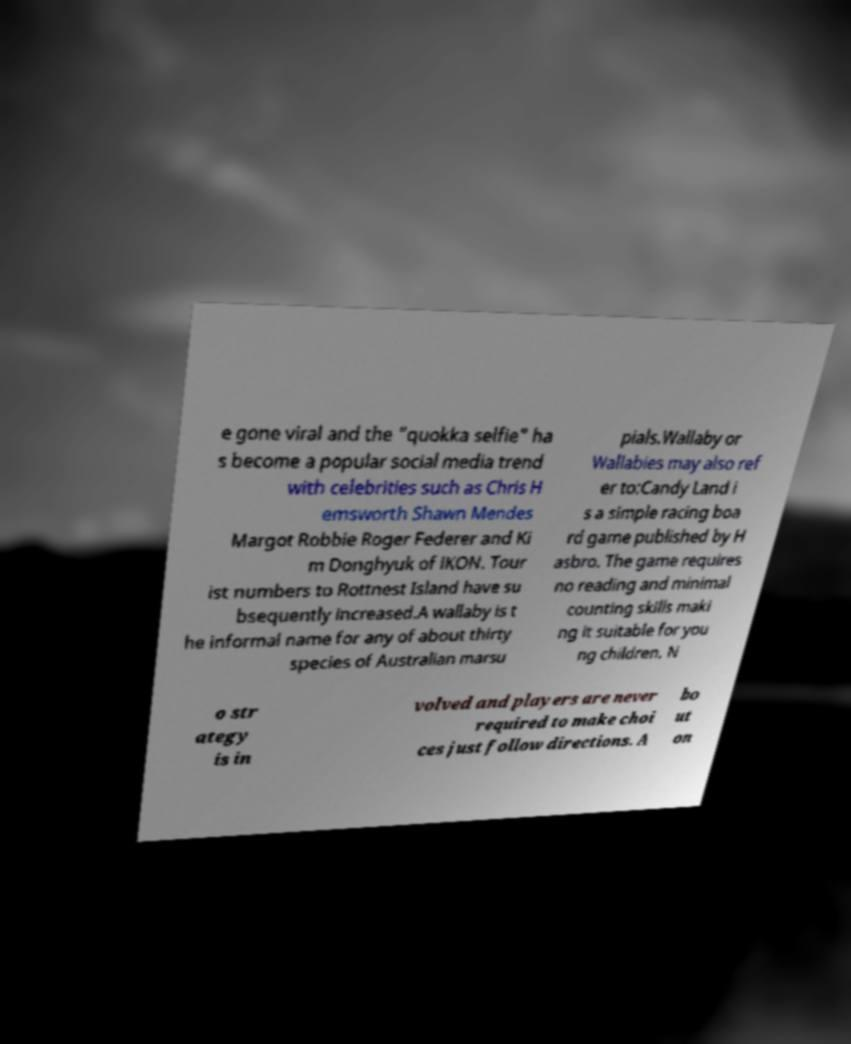Can you read and provide the text displayed in the image?This photo seems to have some interesting text. Can you extract and type it out for me? e gone viral and the "quokka selfie" ha s become a popular social media trend with celebrities such as Chris H emsworth Shawn Mendes Margot Robbie Roger Federer and Ki m Donghyuk of iKON. Tour ist numbers to Rottnest Island have su bsequently increased.A wallaby is t he informal name for any of about thirty species of Australian marsu pials.Wallaby or Wallabies may also ref er to:Candy Land i s a simple racing boa rd game published by H asbro. The game requires no reading and minimal counting skills maki ng it suitable for you ng children. N o str ategy is in volved and players are never required to make choi ces just follow directions. A bo ut on 